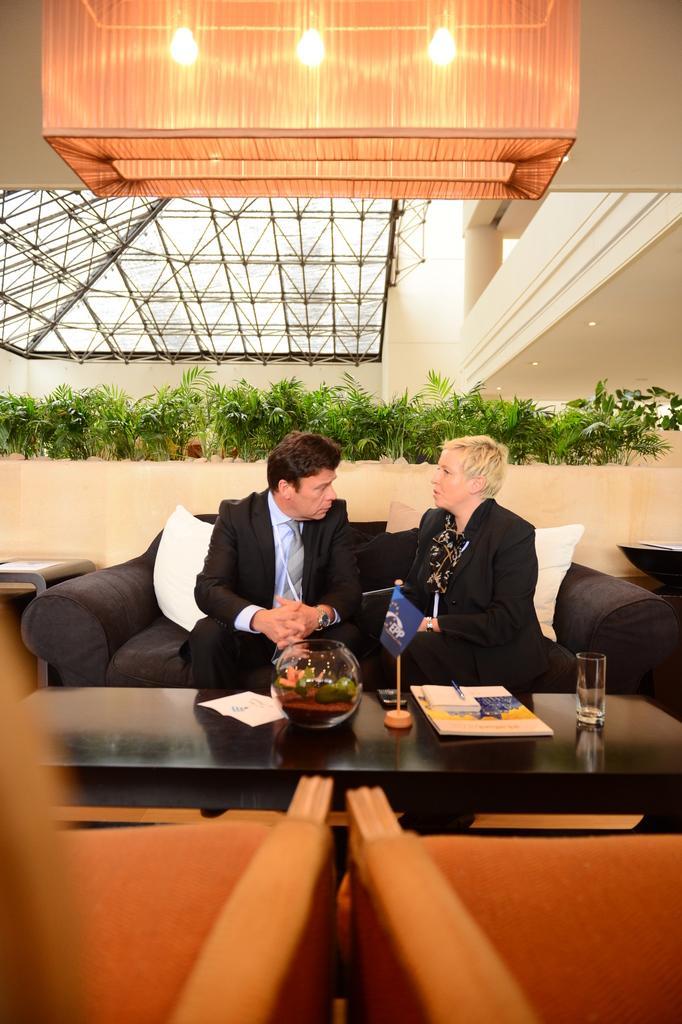Could you give a brief overview of what you see in this image? In this image I can see two people are sitting on a sofa. Here on this table I can see a flag, a glass and few more stuffs. In the background I can see number of plants and few lights. 